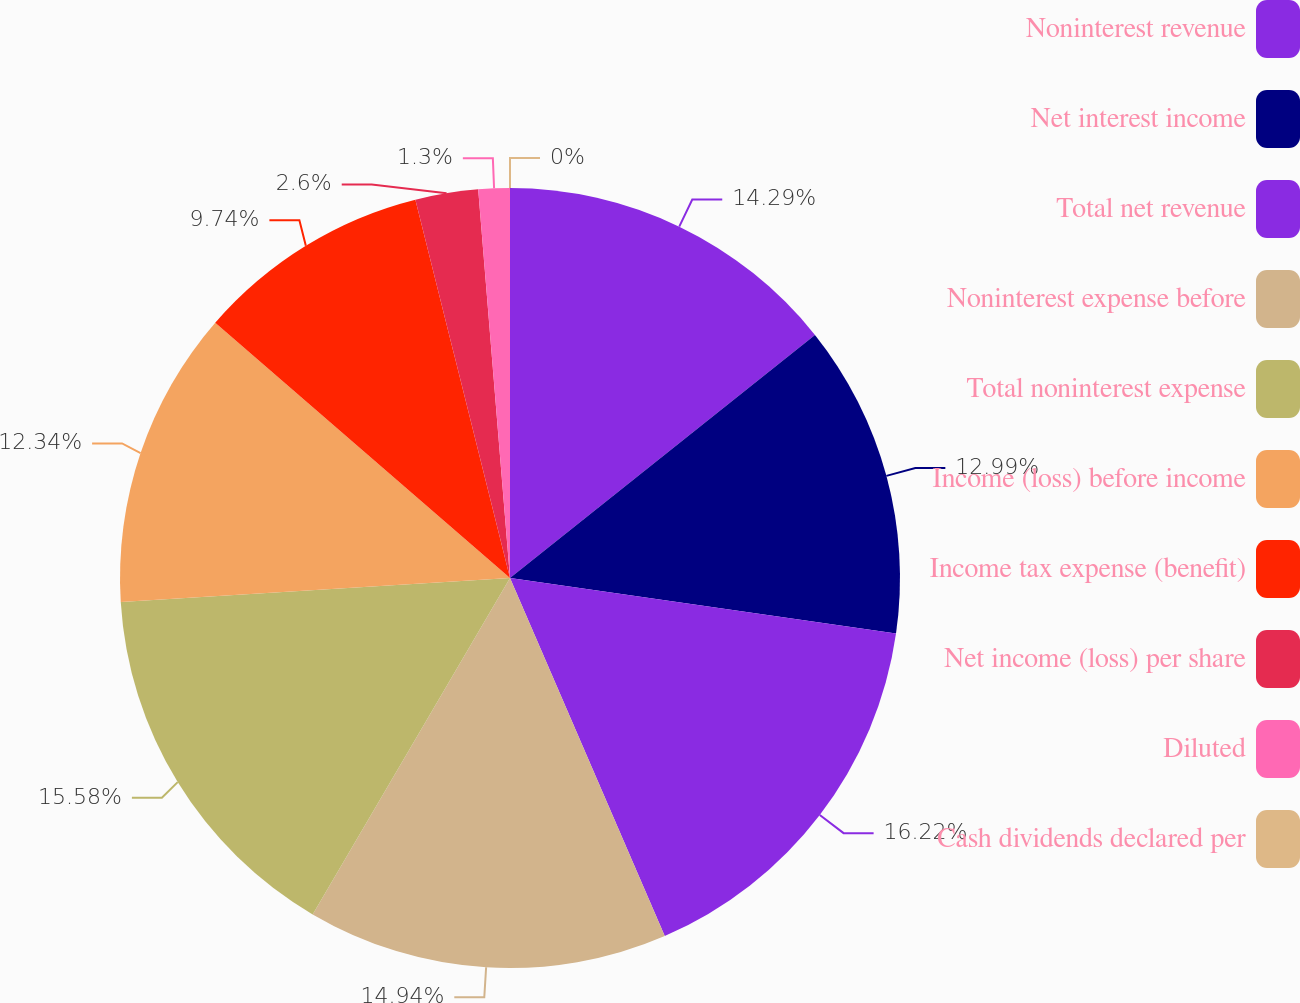<chart> <loc_0><loc_0><loc_500><loc_500><pie_chart><fcel>Noninterest revenue<fcel>Net interest income<fcel>Total net revenue<fcel>Noninterest expense before<fcel>Total noninterest expense<fcel>Income (loss) before income<fcel>Income tax expense (benefit)<fcel>Net income (loss) per share<fcel>Diluted<fcel>Cash dividends declared per<nl><fcel>14.29%<fcel>12.99%<fcel>16.23%<fcel>14.94%<fcel>15.58%<fcel>12.34%<fcel>9.74%<fcel>2.6%<fcel>1.3%<fcel>0.0%<nl></chart> 